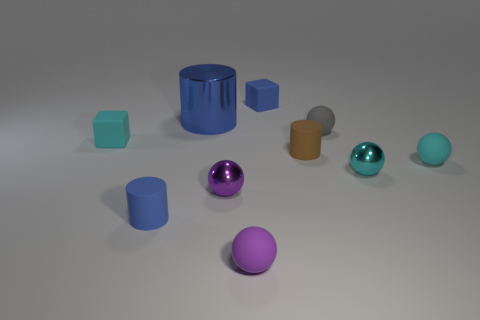There is a rubber object that is both to the right of the large blue cylinder and in front of the small cyan metal thing; what is its color?
Keep it short and to the point. Purple. Is there a blue object that has the same shape as the purple metallic thing?
Provide a succinct answer. No. Are there any tiny matte spheres that are in front of the tiny metal sphere to the left of the tiny brown rubber cylinder?
Make the answer very short. Yes. How many things are tiny cyan blocks that are on the left side of the purple shiny ball or things in front of the large thing?
Provide a succinct answer. 8. What number of objects are either matte cylinders or tiny matte cylinders that are left of the big metal object?
Provide a short and direct response. 2. How big is the sphere right of the small metallic thing right of the rubber thing behind the blue metallic thing?
Offer a very short reply. Small. There is a blue block that is the same size as the brown object; what material is it?
Give a very brief answer. Rubber. Are there any other rubber spheres that have the same size as the gray matte ball?
Provide a short and direct response. Yes. Does the blue matte object behind the cyan metal ball have the same size as the brown cylinder?
Provide a succinct answer. Yes. What shape is the blue object that is behind the tiny blue matte cylinder and in front of the small blue matte block?
Your answer should be compact. Cylinder. 